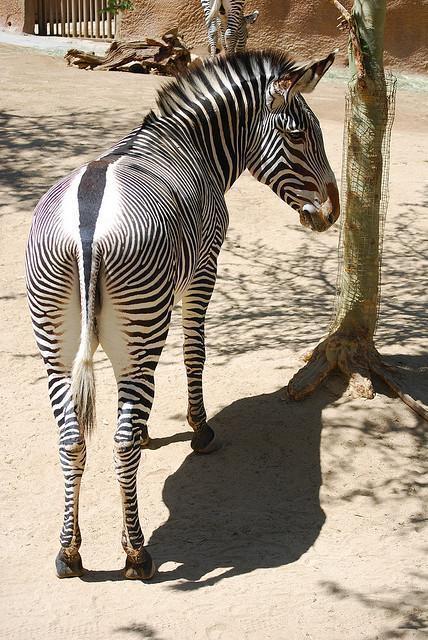How many zebras are in the picture?
Give a very brief answer. 2. 